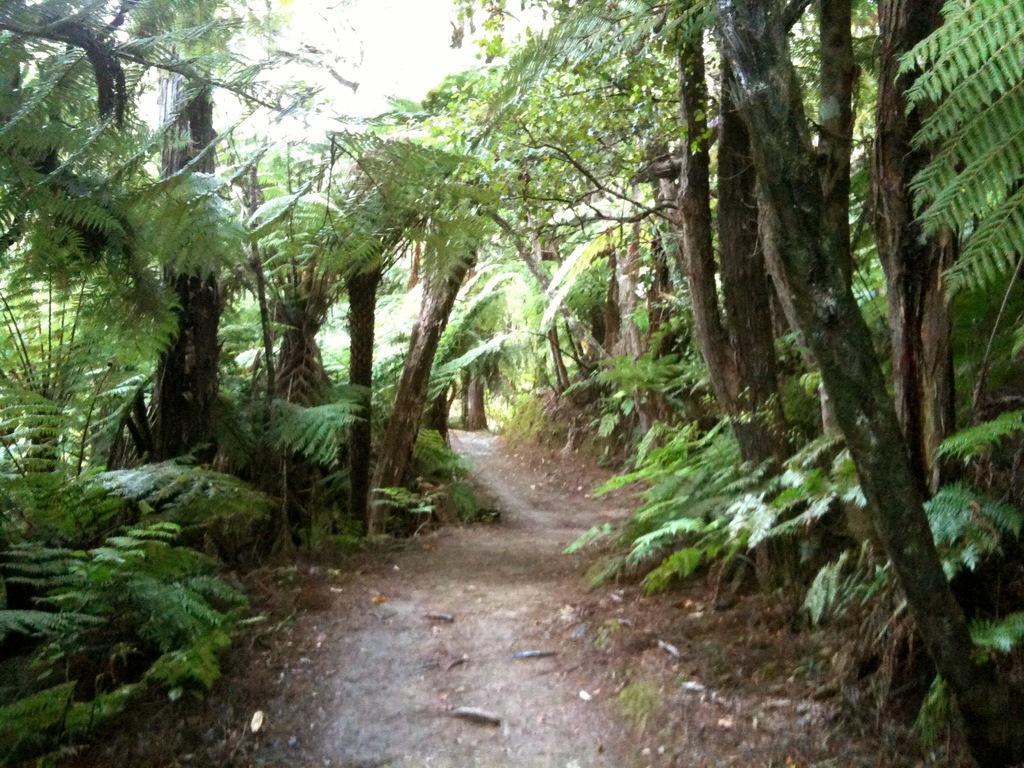In one or two sentences, can you explain what this image depicts? This picture is clicked outside the city. In the foreground we can see the ground and the plants. In the background we can see the trees and a path. 